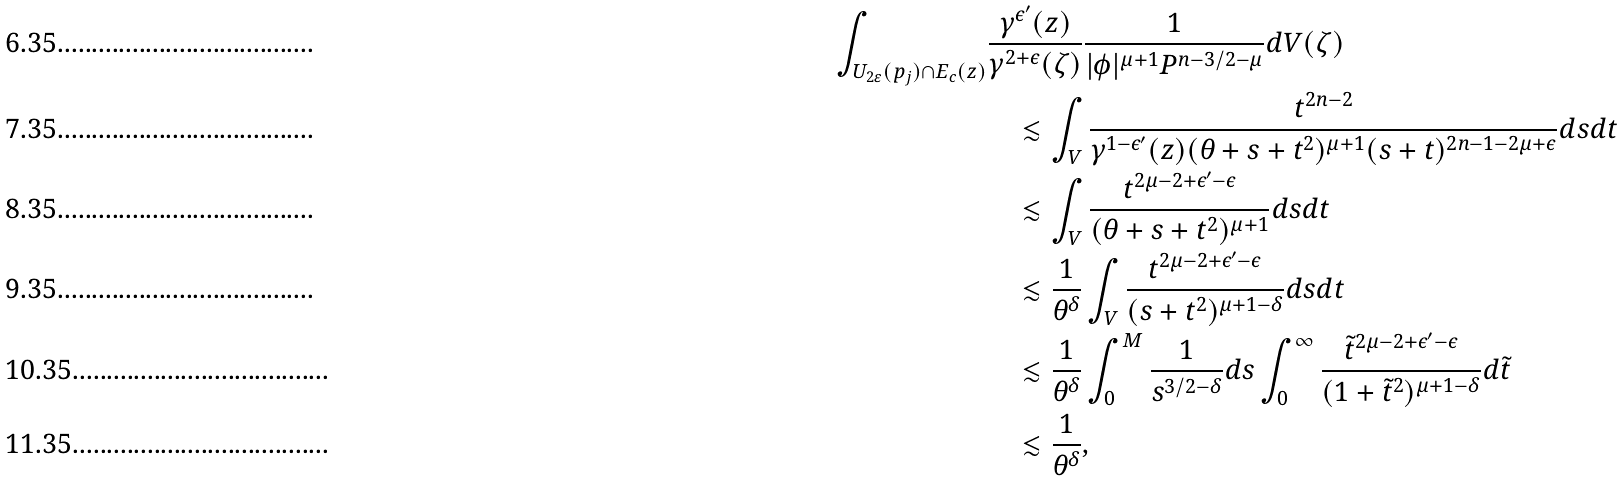<formula> <loc_0><loc_0><loc_500><loc_500>\int _ { U _ { 2 \varepsilon } ( p _ { j } ) \cap E _ { c } ( z ) } & \frac { \gamma ^ { \epsilon ^ { \prime } } ( z ) } { \gamma ^ { 2 + \epsilon } ( \zeta ) } \frac { 1 } { | \phi | ^ { \mu + 1 } P ^ { n - 3 / 2 - \mu } } d V ( \zeta ) \\ & \quad \lesssim \int _ { V } \frac { t ^ { 2 n - 2 } } { \gamma ^ { 1 - \epsilon ^ { \prime } } ( z ) ( \theta + s + t ^ { 2 } ) ^ { \mu + 1 } ( s + t ) ^ { 2 n - 1 - 2 \mu + \epsilon } } d s d t \\ & \quad \lesssim \int _ { V } \frac { t ^ { 2 \mu - 2 + \epsilon ^ { \prime } - \epsilon } } { ( \theta + s + t ^ { 2 } ) ^ { \mu + 1 } } d s d t \\ & \quad \lesssim \frac { 1 } { \theta ^ { \delta } } \int _ { V } \frac { t ^ { 2 \mu - 2 + \epsilon ^ { \prime } - \epsilon } } { ( s + t ^ { 2 } ) ^ { \mu + 1 - \delta } } d s d t \\ & \quad \lesssim \frac { 1 } { \theta ^ { \delta } } \int _ { 0 } ^ { M } \frac { 1 } { s ^ { 3 / 2 - \delta } } d s \int _ { 0 } ^ { \infty } \frac { \tilde { t } ^ { 2 \mu - 2 + \epsilon ^ { \prime } - \epsilon } } { ( 1 + \tilde { t } ^ { 2 } ) ^ { \mu + 1 - \delta } } d \tilde { t } \\ & \quad \lesssim \frac { 1 } { \theta ^ { \delta } } ,</formula> 